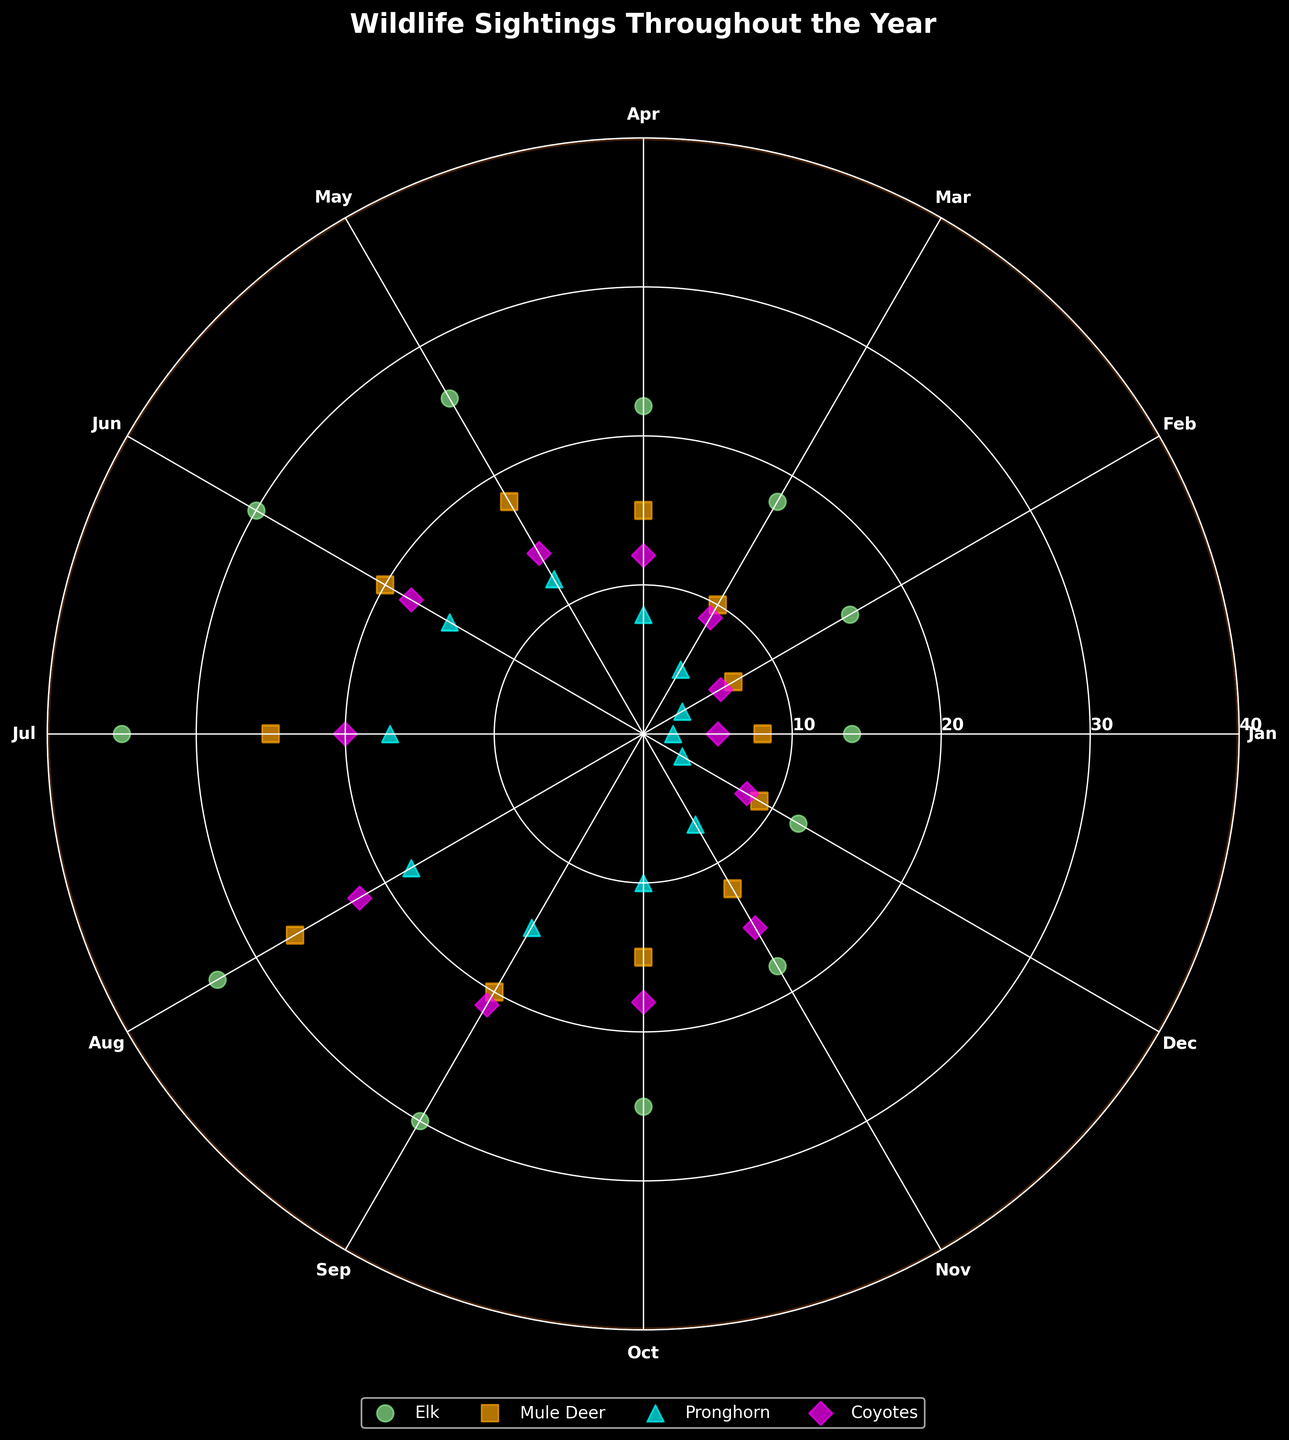What is the title of the plot? The title of the plot is usually displayed at the top of the figure. In this case, the title reads "Wildlife Sightings Throughout the Year," which summarizes the main topic of the chart.
Answer: Wildlife Sightings Throughout the Year Which species has the highest number of sightings in July? Look at the data points for July around the circle's perimeter, and compare the values for each species. The highest number of sightings should be the data point furthest from the center for July. The Elk's marker is furthest out in July.
Answer: Elk What color represents the sightings of Mule Deer? To determine which color corresponds to Mule Deer, observe the labels and legend in the figure. Each species is marked with a unique color. The orange squares in the legend represent Mule Deer sightings.
Answer: Orange How many species are tracked in this chart? The number of species is shown by the different colors and markers in the legend. By counting the distinct items in the legend, we see there are four species: Elk, Mule Deer, Pronghorn, and Coyotes.
Answer: Four Which month has the lowest number of sightings for Pronghorn? Look at the data points for Pronghorn (cyan triangles) and check the distances from the center. The closest point to the center represents the lowest value. In January, the cyan triangle is closest to the center.
Answer: January What is the range of sightings for Coyotes throughout the year? The range is found by subtracting the lowest value from the highest value for Coyotes (magenta diamonds). The lowest number of sightings is in January (5), and the highest is in August (22). The range is 22 - 5.
Answer: 17 During which months do Coyotes have more sightings than Elk? Compare the magenta diamonds (Coyotes) with the light green circles (Elk) for each month. Coyotes have more sightings in December, November, and January.
Answer: December, November, January What's the average number of Elk sightings from June to September? Average is obtained by summing the sightings for Elk from June, July, August, and September, then dividing by the number of months. That is (30 + 35 + 33 + 30) / 4.
Answer: 32 Which species shows the smallest increase in sightings from March to April? Look at the sightings data points for each species in March and April. Calculate the differences: Elk (22 - 18 = 4), Mule Deer (15 - 10 = 5), Pronghorn (8 - 5 = 3), Coyotes (12 - 9 = 3). Pronghorn and Coyotes both show the smallest increase.
Answer: Pronghorn, Coyotes 